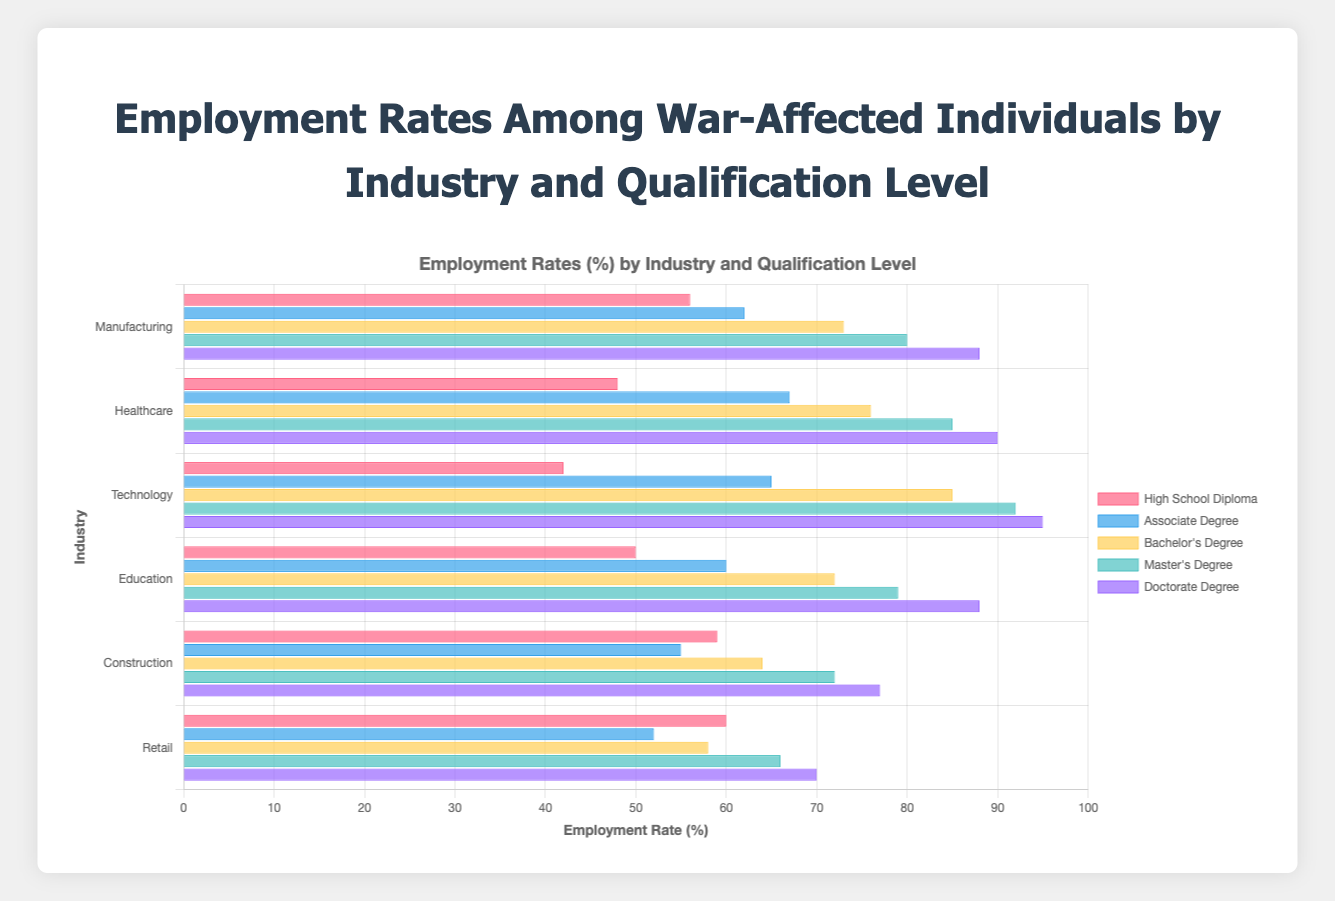Which industry has the highest employment rate for war-affected individuals with a Master's degree? This can be determined by comparing the employment rates for individuals with a Master's degree across all industries. Technology shows the highest rate.
Answer: Technology Which industry has the lowest employment rate for war-affected individuals with a High School Diploma? To answer this, compare the employment rates for individuals with a High School Diploma across all industries. Technology has the lowest rate.
Answer: Technology Which qualification level shows the highest employment rate in the Healthcare industry? By comparing the employment rates in the Healthcare industry across all qualification levels, the Doctorate Degree has the highest rate.
Answer: Doctorate Degree What's the difference in employment rates between war-affected individuals with an Associate Degree and a Bachelor's Degree in the Construction industry? Find the employment rates for both qualification levels in the Construction industry (55 for Associate Degree and 64 for Bachelor's Degree) and subtract the former from the latter. 64 - 55 = 9.
Answer: 9 Which industry shows the most consistent employment rate across different qualification levels, visually apparent by the relative uniformity of bar lengths? Upon visually inspecting the chart for industries where the bar lengths are relatively consistent, Manufacturing shows the most uniform employment rates across different qualification levels.
Answer: Manufacturing How does the employment rate for war-affected individuals with a Doctorate Degree in Retail compare to those with a Bachelor's Degree in Healthcare? Compare the employment rates for the Doctorate Degree in Retail (70) and Bachelor's Degree in Healthcare (76). The rate for Doctorate Degree in Retail is lower.
Answer: Lower What is the average employment rate across all industries for individuals with a Bachelor's Degree? Sum the employment rates for Bachelor's Degree across all industries (73 + 76 + 85 + 72 + 64 + 58) and divide by the number of industries (6). The average rate is (73 + 76 + 85 + 72 + 64 + 58) / 6 = 71.33.
Answer: 71.33 What is the range of employment rates in the Technology industry across all qualification levels? Determine the maximum and minimum employment rates in the Technology industry (42 for High School Diploma and 95 for Doctorate Degree) and subtract the minimum from the maximum. 95 - 42 = 53.
Answer: 53 Which qualification level shows the greatest improvement in employment rates when moving from High School Diploma to Doctorate Degree in Retail? Calculate the differences in employment rates between High School Diploma and Doctorate Degree for each qualification level in Retail. The improvement from High School Diploma (60) to Doctorate Degree (70) is 10.
Answer: Doctorate Degree What is the total employment rate for war-affected individuals with a Master's Degree across all industries combined? Sum the employment rates for Master's Degree across all industries (80 + 85 + 92 + 79 + 72 + 66). The total employment rate is 80 + 85 + 92 + 79 + 72 + 66 = 474.
Answer: 474 